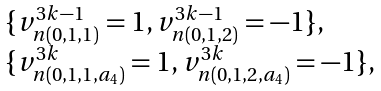Convert formula to latex. <formula><loc_0><loc_0><loc_500><loc_500>\begin{array} { l } \{ v ^ { 3 k - 1 } _ { n ( 0 , 1 , 1 ) } = 1 , v ^ { 3 k - 1 } _ { n ( 0 , 1 , 2 ) } = - 1 \} , \\ \{ v ^ { 3 k } _ { n ( 0 , 1 , 1 , a _ { 4 } ) } = 1 , v ^ { 3 k } _ { n ( 0 , 1 , 2 , a _ { 4 } ) } = - 1 \} , \end{array}</formula> 